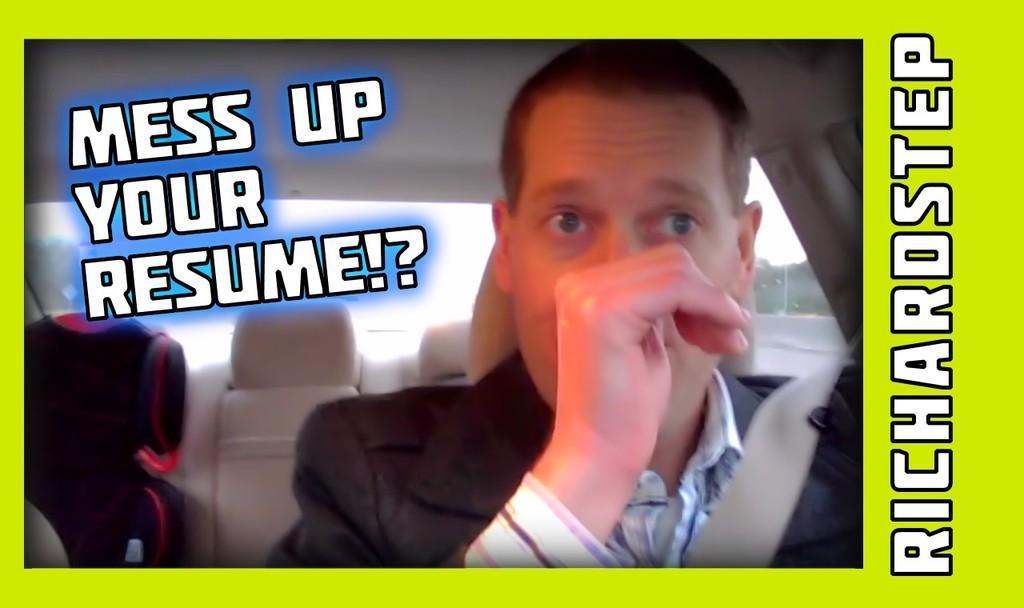How would you summarize this image in a sentence or two? This is an edited image with the borders. On the right there is a person seems to be sitting in the car. In the background we can see the seats and through the window we can see the sky and some other objects and there is a text on the image. 